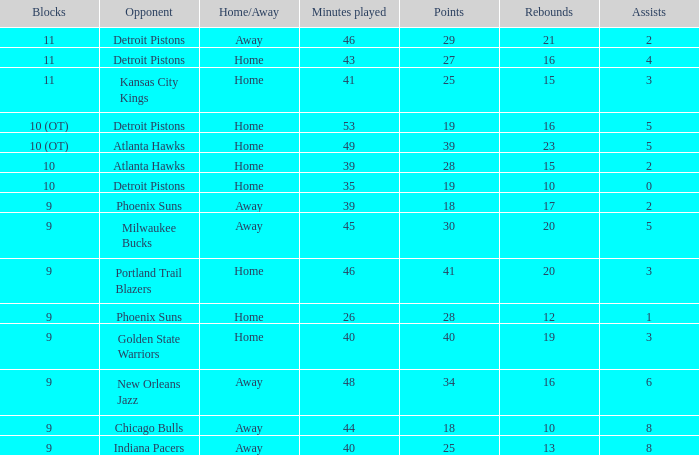How many points were there when there were fewer than 16 rebounds and 5 assists? 0.0. Parse the table in full. {'header': ['Blocks', 'Opponent', 'Home/Away', 'Minutes played', 'Points', 'Rebounds', 'Assists'], 'rows': [['11', 'Detroit Pistons', 'Away', '46', '29', '21', '2'], ['11', 'Detroit Pistons', 'Home', '43', '27', '16', '4'], ['11', 'Kansas City Kings', 'Home', '41', '25', '15', '3'], ['10 (OT)', 'Detroit Pistons', 'Home', '53', '19', '16', '5'], ['10 (OT)', 'Atlanta Hawks', 'Home', '49', '39', '23', '5'], ['10', 'Atlanta Hawks', 'Home', '39', '28', '15', '2'], ['10', 'Detroit Pistons', 'Home', '35', '19', '10', '0'], ['9', 'Phoenix Suns', 'Away', '39', '18', '17', '2'], ['9', 'Milwaukee Bucks', 'Away', '45', '30', '20', '5'], ['9', 'Portland Trail Blazers', 'Home', '46', '41', '20', '3'], ['9', 'Phoenix Suns', 'Home', '26', '28', '12', '1'], ['9', 'Golden State Warriors', 'Home', '40', '40', '19', '3'], ['9', 'New Orleans Jazz', 'Away', '48', '34', '16', '6'], ['9', 'Chicago Bulls', 'Away', '44', '18', '10', '8'], ['9', 'Indiana Pacers', 'Away', '40', '25', '13', '8']]} 